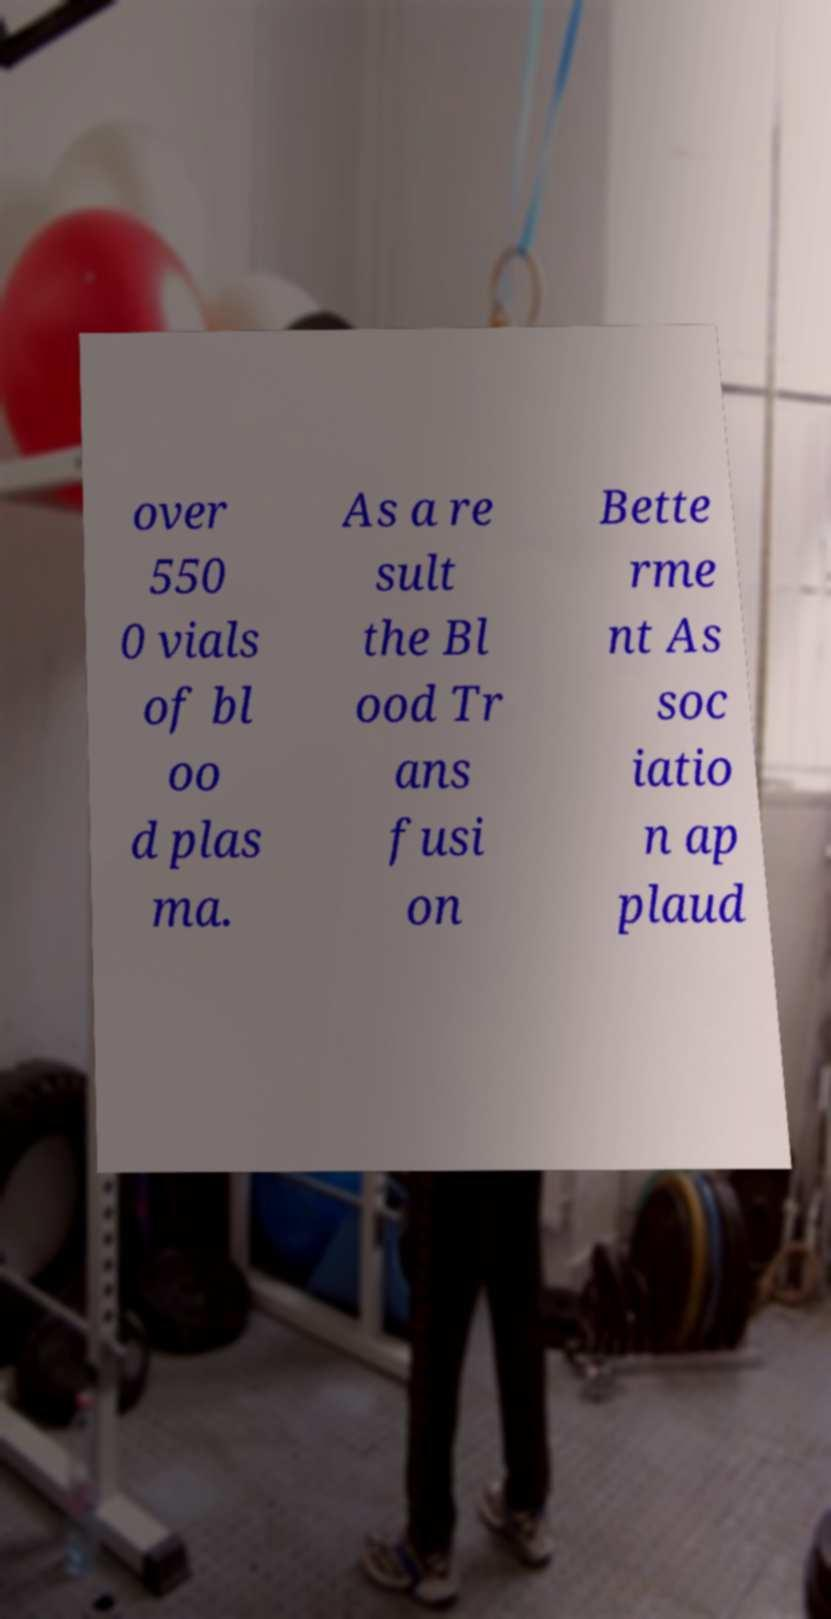Please read and relay the text visible in this image. What does it say? over 550 0 vials of bl oo d plas ma. As a re sult the Bl ood Tr ans fusi on Bette rme nt As soc iatio n ap plaud 